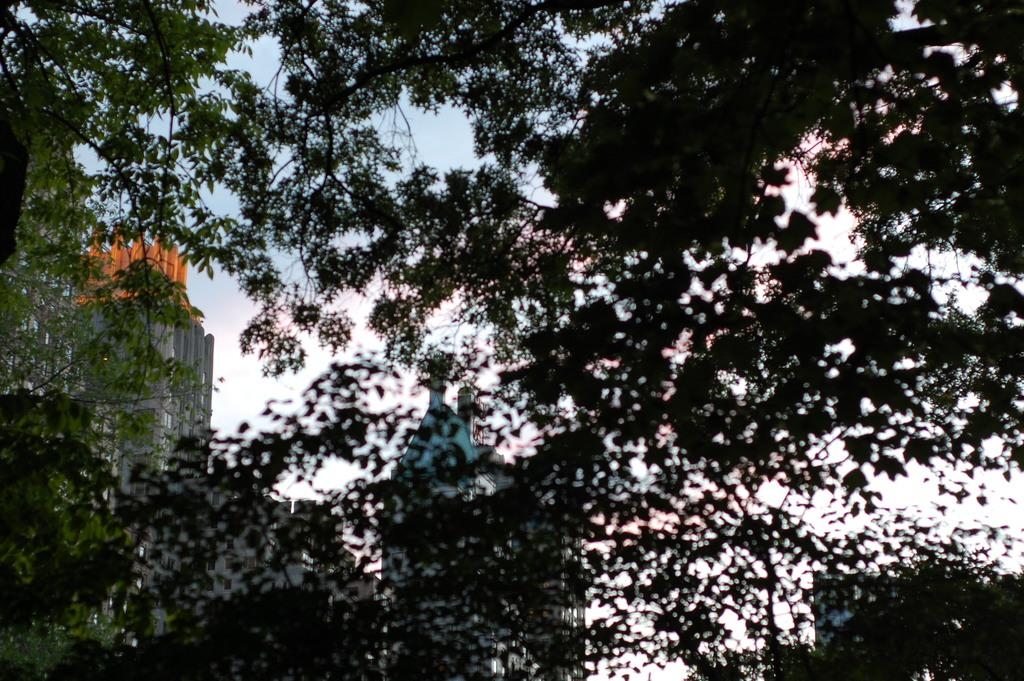What type of structures can be seen in the image? There are buildings in the image. What other natural elements are present in the image? There are trees in the image. How would you describe the sky in the image? The sky is blue and cloudy in the image. Where is the can placed in the image? There is no can present in the image. What type of rod can be seen holding up the trees in the image? There are no rods holding up the trees in the image; the trees are standing on their own. 